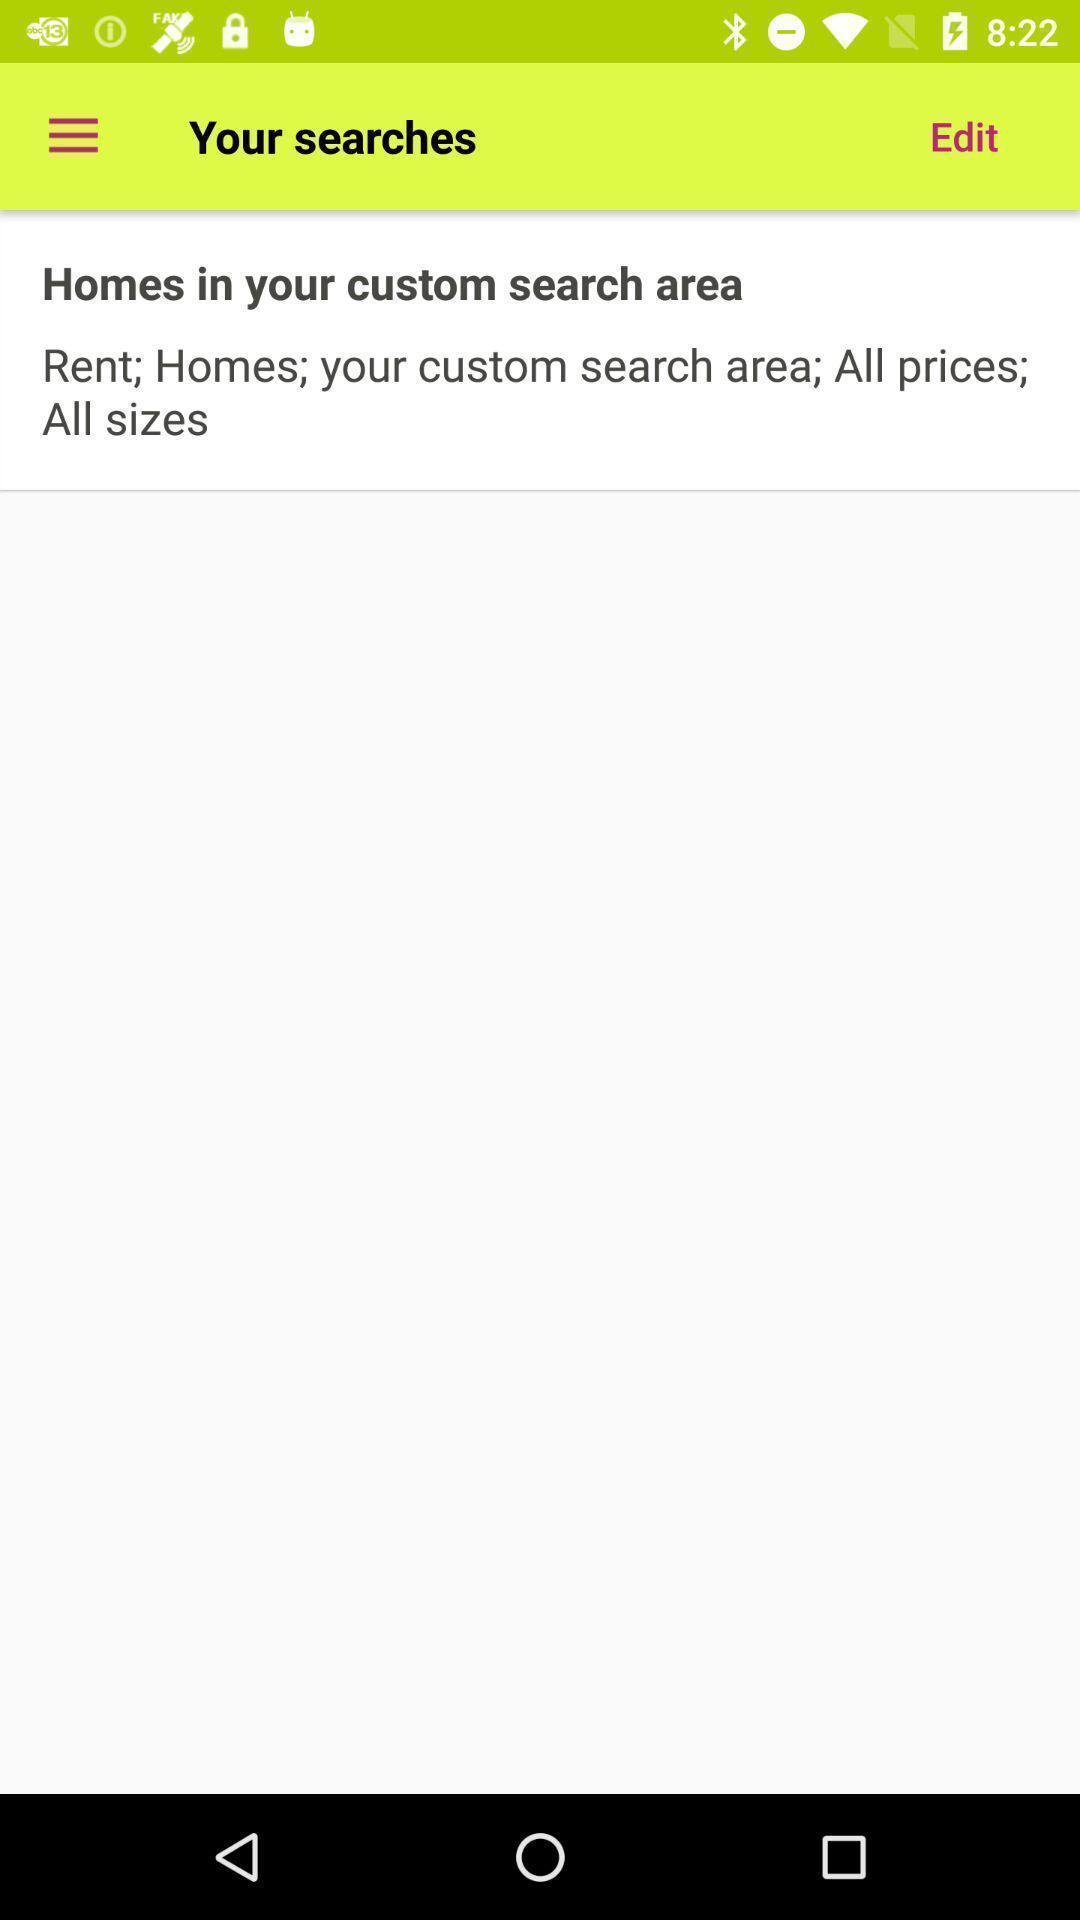Provide a detailed account of this screenshot. Page showing search history on an app. 